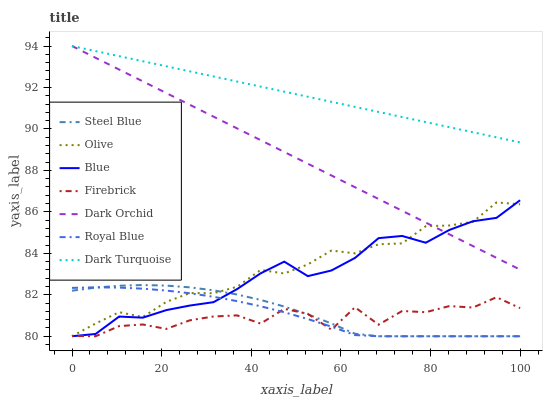Does Firebrick have the minimum area under the curve?
Answer yes or no. Yes. Does Dark Turquoise have the maximum area under the curve?
Answer yes or no. Yes. Does Dark Turquoise have the minimum area under the curve?
Answer yes or no. No. Does Firebrick have the maximum area under the curve?
Answer yes or no. No. Is Dark Turquoise the smoothest?
Answer yes or no. Yes. Is Firebrick the roughest?
Answer yes or no. Yes. Is Firebrick the smoothest?
Answer yes or no. No. Is Dark Turquoise the roughest?
Answer yes or no. No. Does Blue have the lowest value?
Answer yes or no. Yes. Does Dark Turquoise have the lowest value?
Answer yes or no. No. Does Dark Orchid have the highest value?
Answer yes or no. Yes. Does Firebrick have the highest value?
Answer yes or no. No. Is Steel Blue less than Dark Turquoise?
Answer yes or no. Yes. Is Dark Orchid greater than Firebrick?
Answer yes or no. Yes. Does Steel Blue intersect Royal Blue?
Answer yes or no. Yes. Is Steel Blue less than Royal Blue?
Answer yes or no. No. Is Steel Blue greater than Royal Blue?
Answer yes or no. No. Does Steel Blue intersect Dark Turquoise?
Answer yes or no. No. 